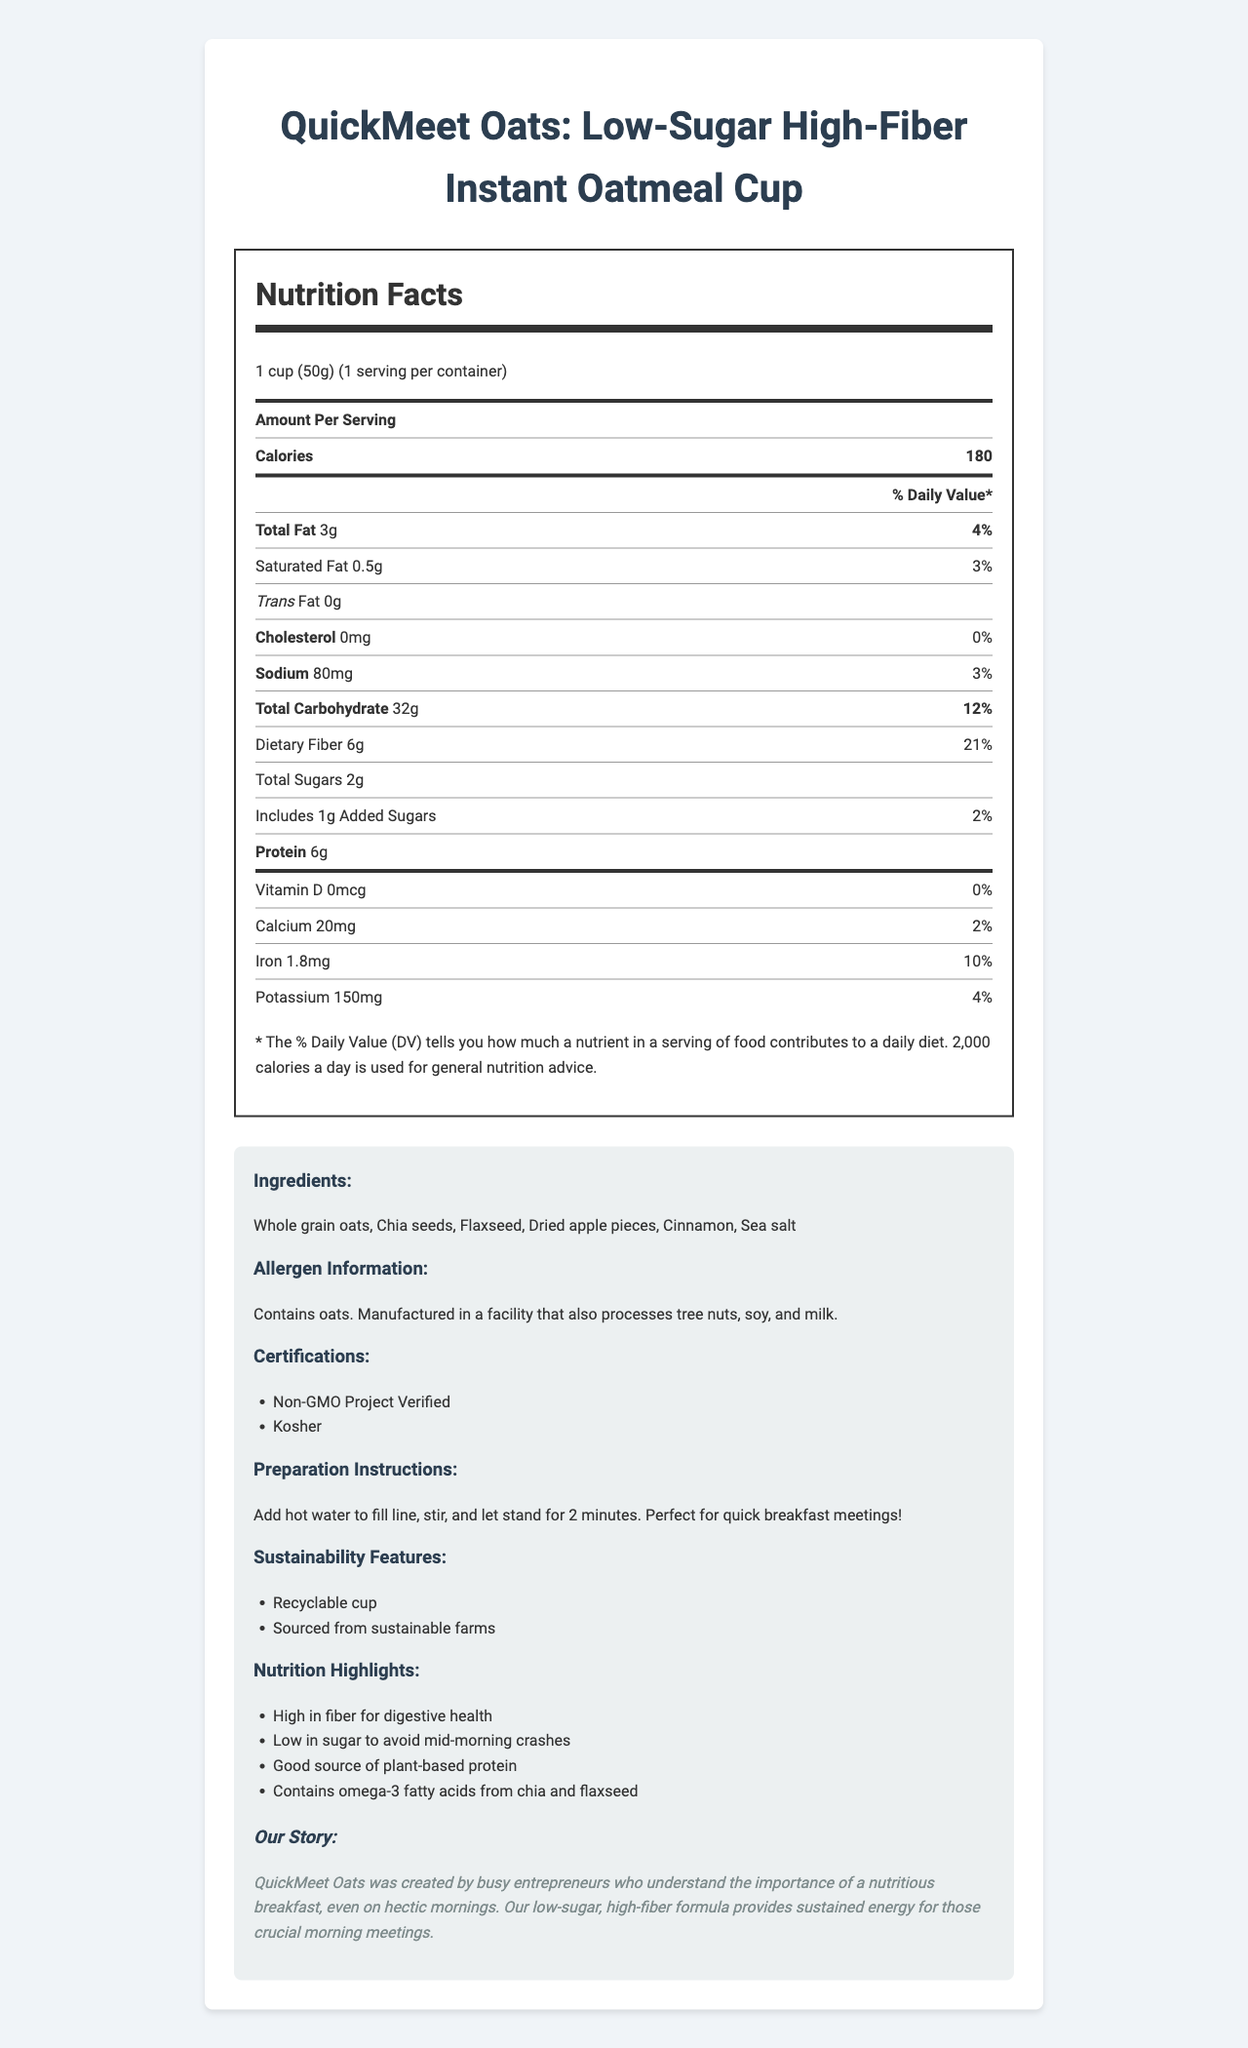how many grams of dietary fiber are in one serving? The nutrition label shows that each serving contains 6 grams of dietary fiber.
Answer: 6 grams what is the % daily value of total carbohydrates per serving? The nutrition label indicates that the % daily value for total carbohydrates in each serving is 12%.
Answer: 12% what certifications does the product have? The product information section lists Non-GMO Project Verified and Kosher as the certifications.
Answer: Non-GMO Project Verified, Kosher how is the oatmeal prepared? The preparation instructions state to add hot water to the fill line, stir, and let stand for 2 minutes.
Answer: Add hot water to fill line, stir, and let stand for 2 minutes. does this product contain any added sugars? The nutrition label specifies that the product contains 1 gram of added sugars.
Answer: Yes which ingredient provides omega-3 fatty acids? A. Dried apple pieces B. Chia seeds C. Cinnamon D. Whole grain oats The nutrition highlights mention that chia and flaxseed provide omega-3 fatty acids.
Answer: B. Chia seeds how many calories are in one serving? A. 150 B. 180 C. 210 D. 240 The nutrition label indicates that each serving contains 180 calories.
Answer: B. 180 is the product high in cholesterol? The nutrition label states that there is 0mg of cholesterol per serving, which is 0% of the daily value.
Answer: No summarize the main idea of the document. This summary covers the entire content provided in the nutrition label and product information sections.
Answer: The document provides comprehensive nutritional information about "QuickMeet Oats: Low-Sugar High-Fiber Instant Oatmeal Cup", including serving size, calories, fat, carbohydrates, proteins, vitamins, minerals, ingredients, preparation instructions, allergens, certifications, sustainability features, and a brand story. which facilities process this product? A. Facilities processing tree nuts, soy, and milk B. Facilities processing peanuts and gluten C. Dairy-only facilities D. Soy-free facilities The allergen information indicates that the product is manufactured in a facility that processes tree nuts, soy, and milk.
Answer: A. Facilities processing tree nuts, soy, and milk what percentage of the daily value for sodium does one serving provide? The nutrition label lists that one serving provides 3% of the daily value for sodium.
Answer: 3% are there any vitamins present in the oatmeal? The nutrition label lists iron, calcium, and potassium as present nutrients, although vitamin D is 0%.
Answer: Yes what is the protein content per serving? The nutrition label shows that each serving contains 6 grams of protein.
Answer: 6 grams is this product suitable for people with tree nut allergies? The product is manufactured in a facility that processes tree nuts, which could be a concern for people with tree nut allergies.
Answer: No what is the brand story? The brand story section provides details about the origin and purpose of QuickMeet Oats.
Answer: QuickMeet Oats was created by busy entrepreneurs who understand the importance of a nutritious breakfast, even on hectic mornings. Their low-sugar, high-fiber formula provides sustained energy for crucial morning meetings. what is the source of the omega-3 fatty acids in this product? Although the label mentions the presence of omega-3 fatty acids in chia and flaxseed, it doesn't specify the exact amounts or the primary source in the product.
Answer: Cannot be determined 